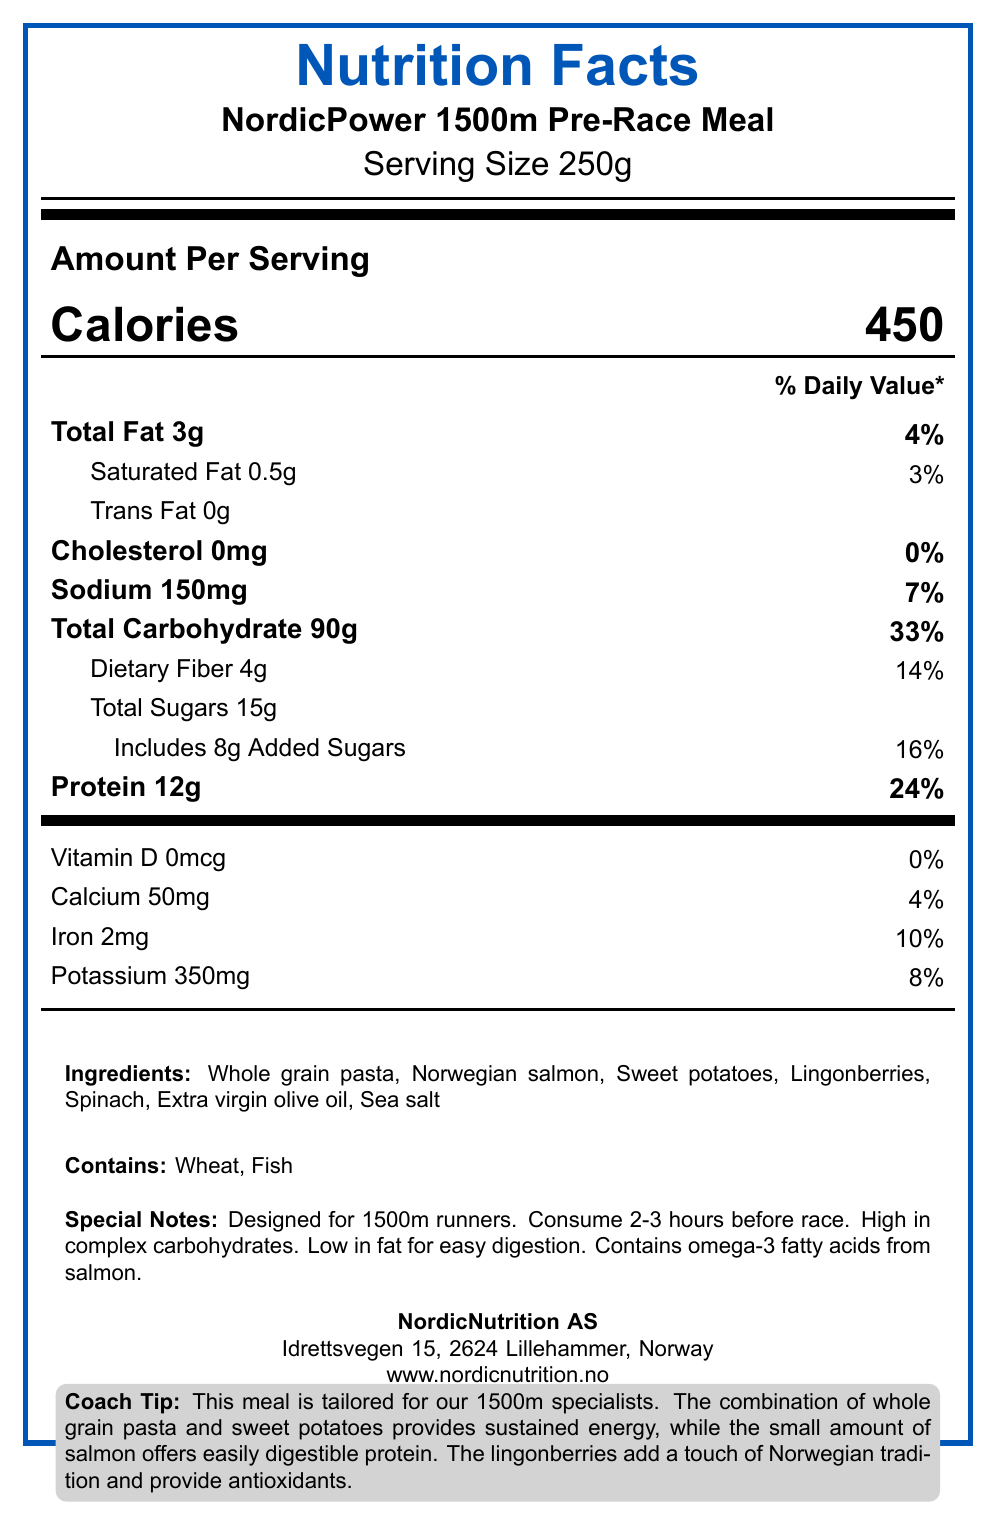How many calories are in one serving? According to the document, one serving of the NordicPower 1500m Pre-Race Meal contains 450 calories.
Answer: 450 What is the serving size? The document specifies that the serving size for the NordicPower 1500m Pre-Race Meal is 250g.
Answer: 250g How much total fat is in one serving? The document lists the total fat content per serving as 3g.
Answer: 3g What percentage of the daily value of protein does one serving provide? The document shows that one serving provides 12g of protein, which is 24% of the daily value.
Answer: 24% Which two main ingredients are allergens? The document states under allergens that the product contains wheat and fish.
Answer: Wheat, Fish What is the amount of sodium per serving? The document indicates that one serving contains 150mg of sodium.
Answer: 150mg What are the main sources of carbohydrates in this meal? A. Whole grain pasta and sweet potatoes B. Salmon and spinach C. Ligonberries and olive oil D. Sea salt and spinach In the ingredients list, whole grain pasta and sweet potatoes are the sources of carbohydrates.
Answer: A. Whole grain pasta and sweet potatoes What is the percentage of the daily value for calcium provided by one serving? A. 8% B. 10% C. 4% D. 12% The document shows that one serving provides 50mg of calcium, which is 4% of the daily value.
Answer: C. 4% Is this meal high in fat? The document mentions that the meal is low in fat for easy digestion, with a total fat content of 3g per serving.
Answer: No Summarize the purpose and nutritional profile of the NordicPower 1500m Pre-Race Meal. The document outlines that the meal is tailored for 1500m specialists, meant to be consumed 2-3 hours before the race, is high in complex carbohydrates and low in fat, with specific beneficial ingredients such as Norwegian salmon and lingonberries.
Answer: The NordicPower 1500m Pre-Race Meal is designed specifically for 1500m runners. It provides sustained energy through high complex carbohydrate content, contains easily digestible protein from salmon, and is low in fat for easy digestion. It also includes antioxidants from lingonberries and omega-3 fatty acids from salmon. What is the total amount of sugars, including added sugars, in one serving? The document states that there are 15g of total sugars, including 8g of added sugars, per serving.
Answer: 15g total sugars, including 8g added sugars What is the main benefit of the lingonberries in this pre-race meal? According to the coach tip at the end of the document, the lingonberries provide antioxidants.
Answer: Antioxidants Who is the manufacturer of this product and where are they located? The document lists the manufacturer as NordicNutrition AS, located at Idrettsvegen 15, 2624 Lillehammer, Norway.
Answer: NordicNutrition AS, Idrettsvegen 15, 2624 Lillehammer, Norway How much potassium is in a serving of the NordicPower 1500m Pre-Race Meal? The document states that each serving contains 350mg of potassium.
Answer: 350mg How should this meal be consumed according to the special notes? The special notes section of the document advises consuming the meal 2-3 hours before the race.
Answer: Consume 2-3 hours before race Does this meal contain trans fat? The document indicates that the meal contains 0g of trans fat.
Answer: No What is the primary source of protein in this pre-race meal? The ingredients list and the coach tip specify that Norwegian salmon is the primary source of protein.
Answer: Norwegian salmon What is the main purpose of the NordicPower 1500m Pre-Race Meal? The document specifies that the meal is designed for 1500m runners, high in complex carbohydrates, low in fat, and contains beneficial ingredients like Norwegian salmon and lingonberries.
Answer: To provide energy and nutrition specifically designed for 1500m runners by offering sustained energy, easily digestible protein, and antioxidants. How much saturated fat does one serving contain, and what is the percentage of the daily value? The document states that one serving contains 0.5g of saturated fat, which is 3% of the daily value.
Answer: 0.5g, 3% What is the website for the product manufacturer NordicNutrition AS? The manufacturer information section provides the website www.nordicnutrition.no.
Answer: www.nordicnutrition.no What is the process of rendering the nutritional facts label? The document does not provide any details about the process of rendering the nutritional facts label.
Answer: Not enough information 